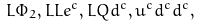<formula> <loc_0><loc_0><loc_500><loc_500>L \Phi _ { 2 } , L L e ^ { c } , L Q d ^ { c } , u ^ { c } d ^ { c } d ^ { c } ,</formula> 